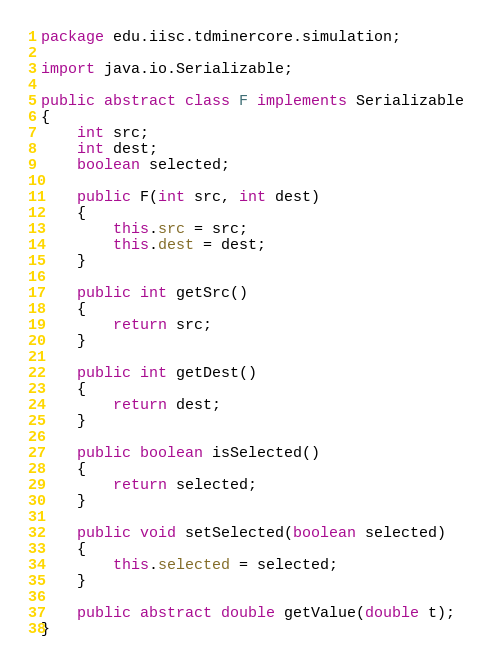<code> <loc_0><loc_0><loc_500><loc_500><_Java_>package edu.iisc.tdminercore.simulation;

import java.io.Serializable;

public abstract class F implements Serializable
{
    int src;
    int dest;
    boolean selected;

    public F(int src, int dest)
    {
        this.src = src;
        this.dest = dest;
    }

    public int getSrc()
    {
        return src;
    }

    public int getDest()
    {
        return dest;
    }

    public boolean isSelected()
    {
        return selected;
    }

    public void setSelected(boolean selected)
    {
        this.selected = selected;
    }

    public abstract double getValue(double t);
}
</code> 